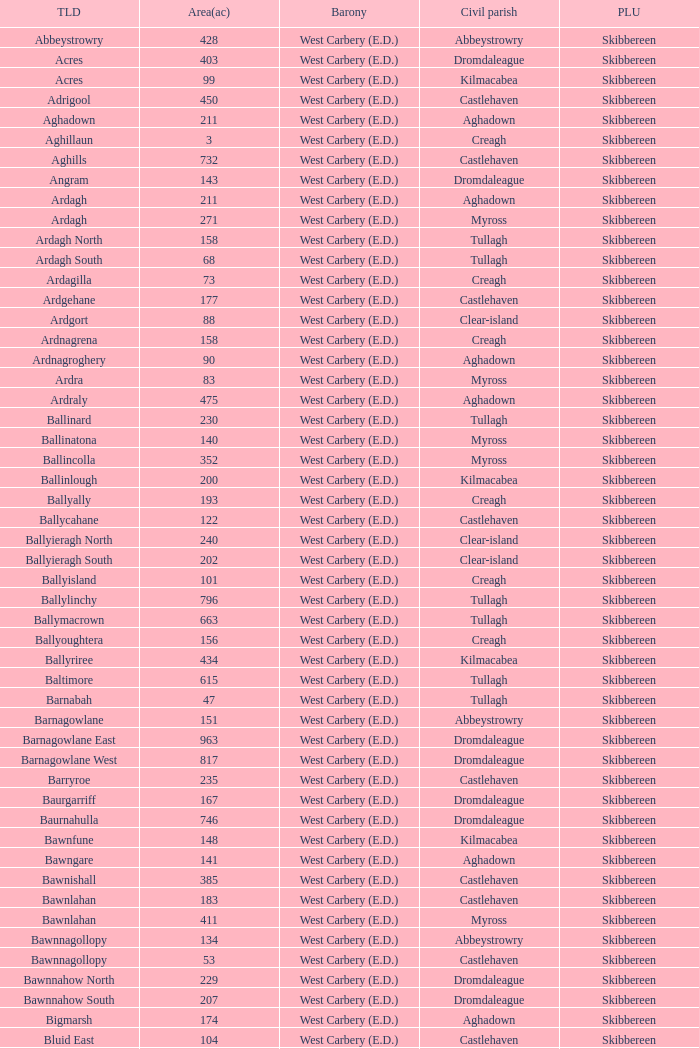What are the Poor Law Unions when the area (in acres) is 142? Skibbereen. 